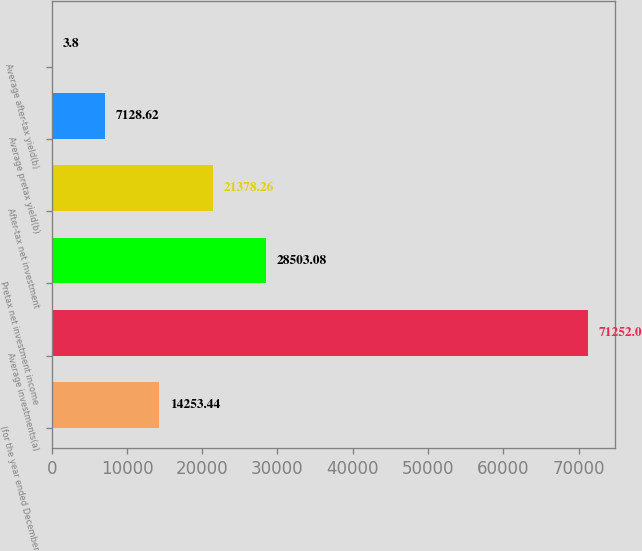Convert chart. <chart><loc_0><loc_0><loc_500><loc_500><bar_chart><fcel>(for the year ended December<fcel>Average investments(a)<fcel>Pretax net investment income<fcel>After-tax net investment<fcel>Average pretax yield(b)<fcel>Average after-tax yield(b)<nl><fcel>14253.4<fcel>71252<fcel>28503.1<fcel>21378.3<fcel>7128.62<fcel>3.8<nl></chart> 